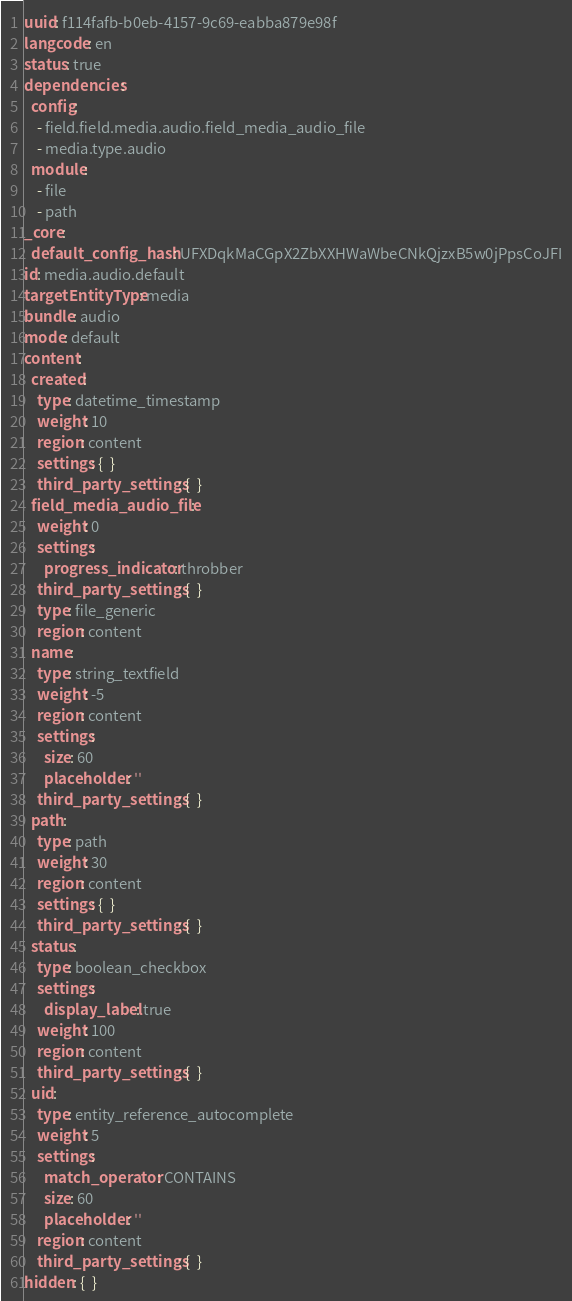Convert code to text. <code><loc_0><loc_0><loc_500><loc_500><_YAML_>uuid: f114fafb-b0eb-4157-9c69-eabba879e98f
langcode: en
status: true
dependencies:
  config:
    - field.field.media.audio.field_media_audio_file
    - media.type.audio
  module:
    - file
    - path
_core:
  default_config_hash: UFXDqkMaCGpX2ZbXXHWaWbeCNkQjzxB5w0jPpsCoJFI
id: media.audio.default
targetEntityType: media
bundle: audio
mode: default
content:
  created:
    type: datetime_timestamp
    weight: 10
    region: content
    settings: {  }
    third_party_settings: {  }
  field_media_audio_file:
    weight: 0
    settings:
      progress_indicator: throbber
    third_party_settings: {  }
    type: file_generic
    region: content
  name:
    type: string_textfield
    weight: -5
    region: content
    settings:
      size: 60
      placeholder: ''
    third_party_settings: {  }
  path:
    type: path
    weight: 30
    region: content
    settings: {  }
    third_party_settings: {  }
  status:
    type: boolean_checkbox
    settings:
      display_label: true
    weight: 100
    region: content
    third_party_settings: {  }
  uid:
    type: entity_reference_autocomplete
    weight: 5
    settings:
      match_operator: CONTAINS
      size: 60
      placeholder: ''
    region: content
    third_party_settings: {  }
hidden: {  }
</code> 